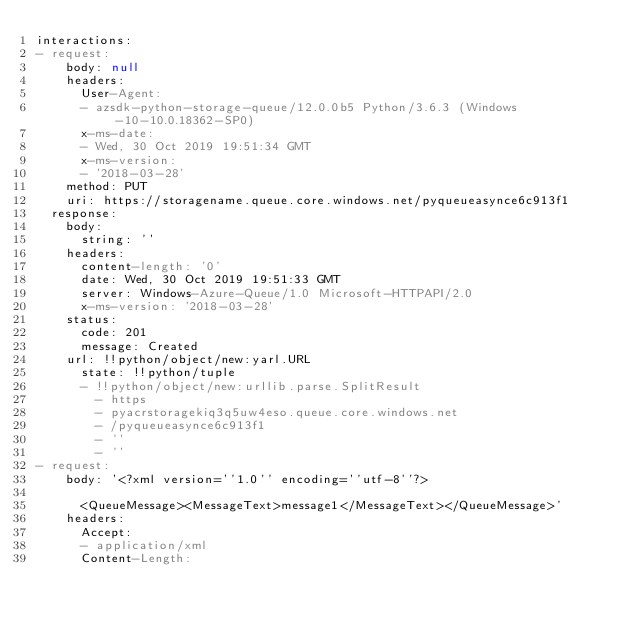Convert code to text. <code><loc_0><loc_0><loc_500><loc_500><_YAML_>interactions:
- request:
    body: null
    headers:
      User-Agent:
      - azsdk-python-storage-queue/12.0.0b5 Python/3.6.3 (Windows-10-10.0.18362-SP0)
      x-ms-date:
      - Wed, 30 Oct 2019 19:51:34 GMT
      x-ms-version:
      - '2018-03-28'
    method: PUT
    uri: https://storagename.queue.core.windows.net/pyqueueasynce6c913f1
  response:
    body:
      string: ''
    headers:
      content-length: '0'
      date: Wed, 30 Oct 2019 19:51:33 GMT
      server: Windows-Azure-Queue/1.0 Microsoft-HTTPAPI/2.0
      x-ms-version: '2018-03-28'
    status:
      code: 201
      message: Created
    url: !!python/object/new:yarl.URL
      state: !!python/tuple
      - !!python/object/new:urllib.parse.SplitResult
        - https
        - pyacrstoragekiq3q5uw4eso.queue.core.windows.net
        - /pyqueueasynce6c913f1
        - ''
        - ''
- request:
    body: '<?xml version=''1.0'' encoding=''utf-8''?>

      <QueueMessage><MessageText>message1</MessageText></QueueMessage>'
    headers:
      Accept:
      - application/xml
      Content-Length:</code> 